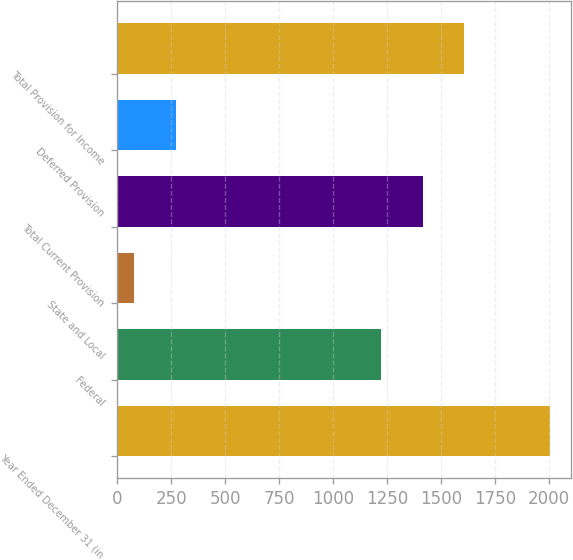Convert chart. <chart><loc_0><loc_0><loc_500><loc_500><bar_chart><fcel>Year Ended December 31 (in<fcel>Federal<fcel>State and Local<fcel>Total Current Provision<fcel>Deferred Provision<fcel>Total Provision for Income<nl><fcel>2004<fcel>1223<fcel>78<fcel>1415.6<fcel>270.6<fcel>1608.2<nl></chart> 